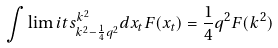Convert formula to latex. <formula><loc_0><loc_0><loc_500><loc_500>\int \lim i t s ^ { k ^ { 2 } } _ { k ^ { 2 } - \frac { 1 } { 4 } q ^ { 2 } } d x _ { t } F ( x _ { t } ) = \frac { 1 } { 4 } q ^ { 2 } F ( k ^ { 2 } )</formula> 